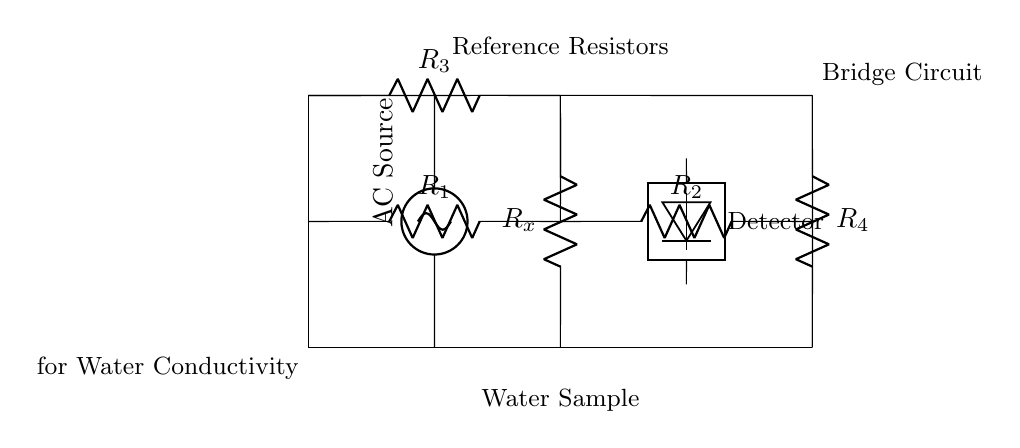What type of circuit is this? This circuit is a bridge circuit. A bridge circuit typically consists of several resistors arranged in two branches that can balance against an unknown resistor or impedance.
Answer: Bridge circuit What does the symbol at the bottom represent? The symbol at the bottom represents a water sample, which is the medium whose conductivity is being measured in this bridge circuit.
Answer: Water sample How many resistors are in the circuit? There are four resistors visible in the circuit diagram (R1, R2, R3, R4) plus the unknown resistance (Rx), totaling five resistors.
Answer: Five resistors What is the purpose of the AC source? The AC source provides an alternating current that is necessary for measuring the conductivity of the water sample by creating oscillations that facilitate detection.
Answer: To measure conductivity Which component acts as a detector in the circuit? The detector is located on the right side of the circuit, indicated by the detector symbol; it measures the difference in potential between the two branches of the bridge circuit.
Answer: Detector What is the function of resistor R3? Resistor R3 is part of the bridge configuration that helps in balancing the circuit. It provides a reference resistance against which the unknown resistance (Rx) is measured.
Answer: Reference resistor How is the measurement taken in this circuit? The measurement is taken by analyzing the potential difference detected by the detector, which indicates whether the bridge is balanced or not, allowing for the calculation of conductivity based on Rx.
Answer: By potential difference detection 